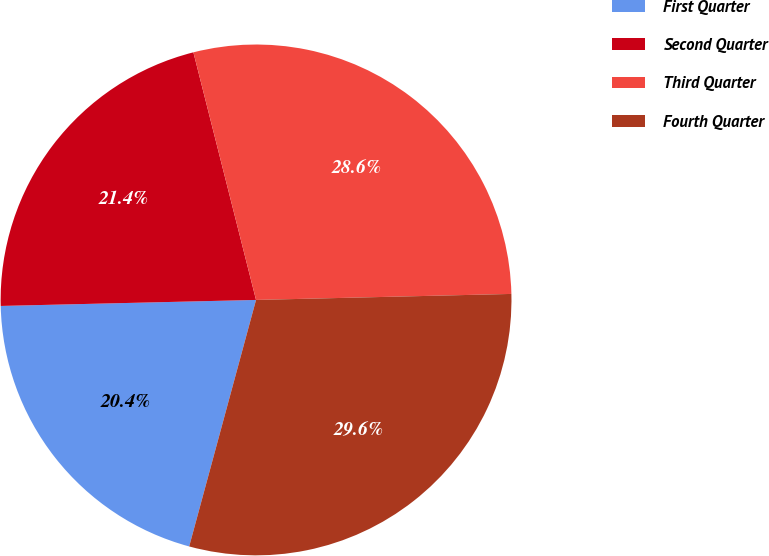<chart> <loc_0><loc_0><loc_500><loc_500><pie_chart><fcel>First Quarter<fcel>Second Quarter<fcel>Third Quarter<fcel>Fourth Quarter<nl><fcel>20.41%<fcel>21.43%<fcel>28.57%<fcel>29.59%<nl></chart> 